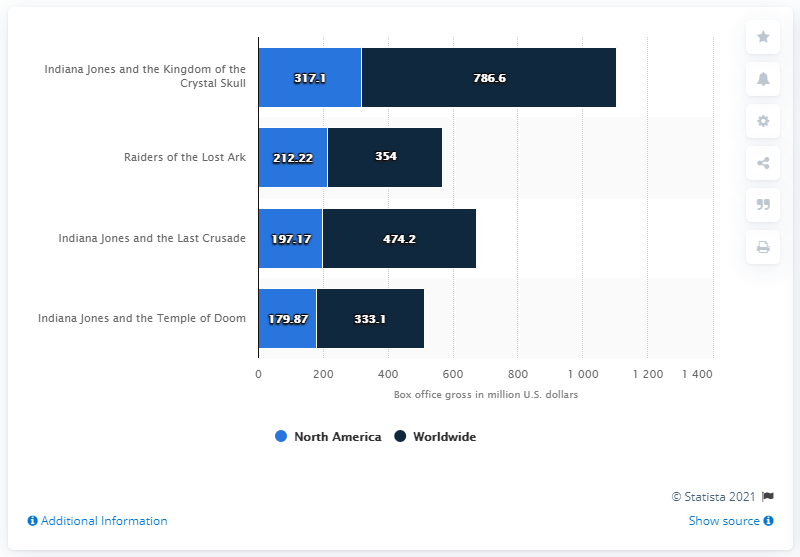Identify some key points in this picture. The highest box office revenue to date is 786.6 million U.S. dollars. The box office revenue of "Raiders of the Lost Ark" was $566.22 million in the United States. As of January 2018, the domestic gross box office revenue of "Raiders of the Lost Ark" was 212.22 million U.S. dollars. 